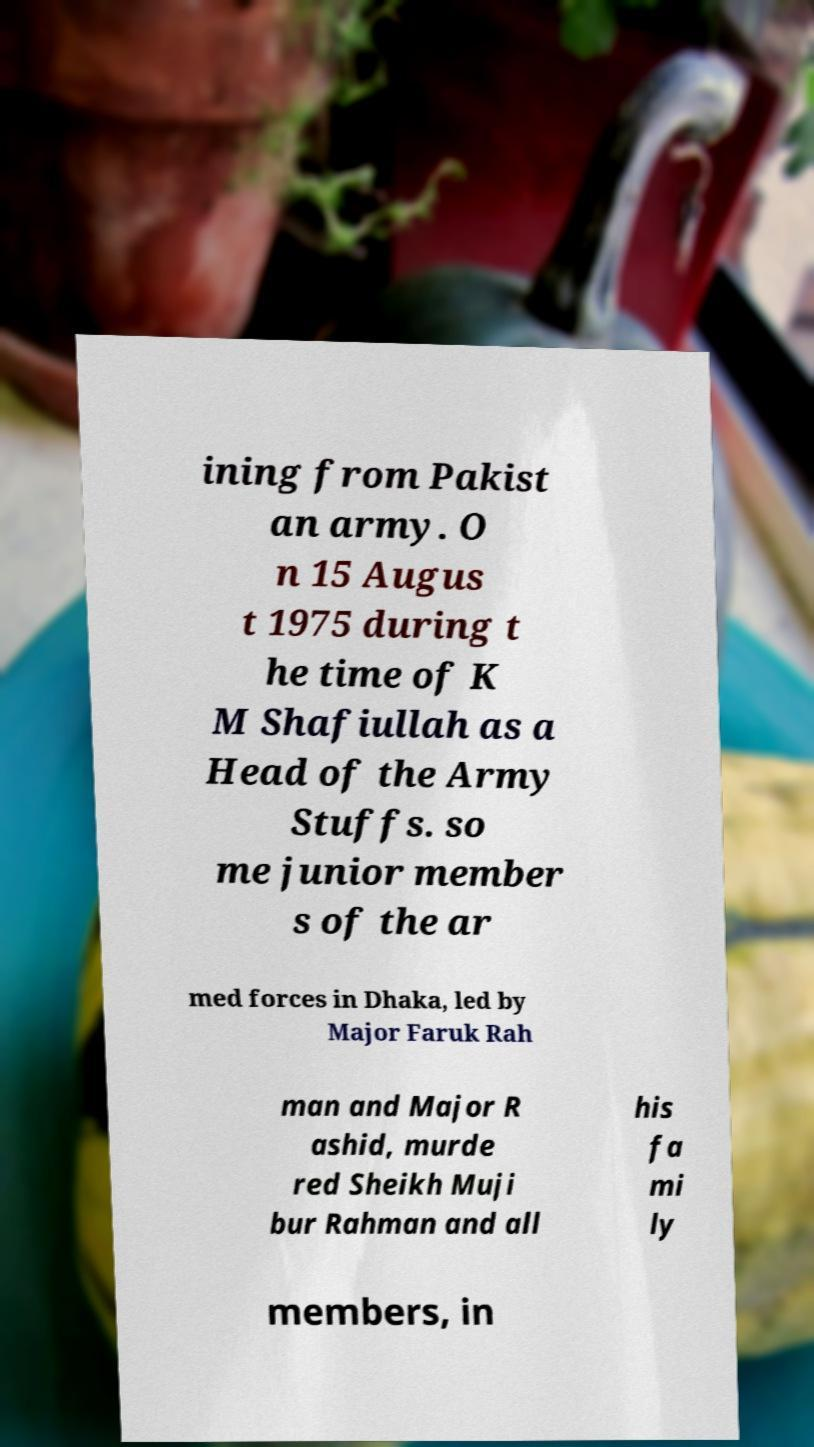I need the written content from this picture converted into text. Can you do that? ining from Pakist an army. O n 15 Augus t 1975 during t he time of K M Shafiullah as a Head of the Army Stuffs. so me junior member s of the ar med forces in Dhaka, led by Major Faruk Rah man and Major R ashid, murde red Sheikh Muji bur Rahman and all his fa mi ly members, in 